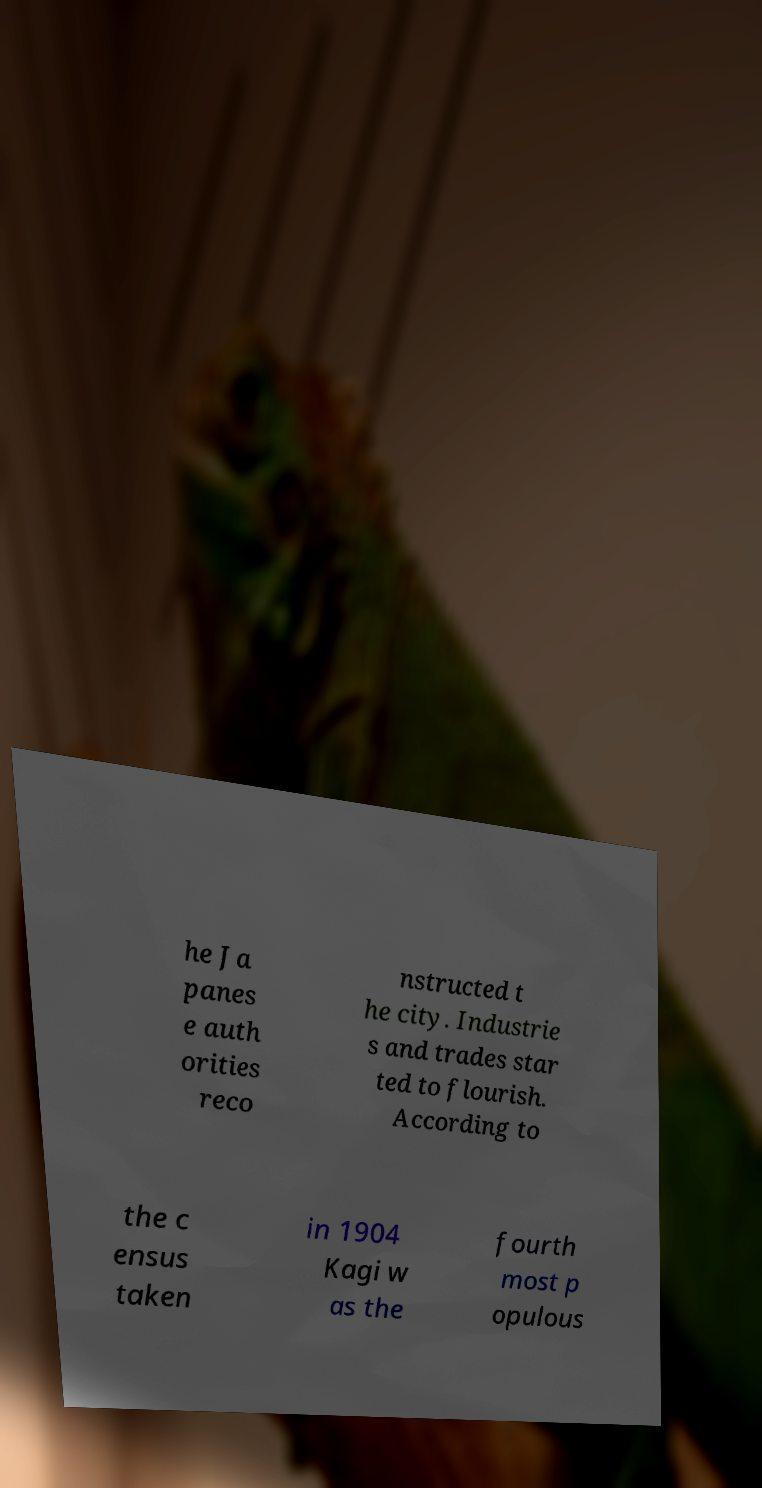I need the written content from this picture converted into text. Can you do that? he Ja panes e auth orities reco nstructed t he city. Industrie s and trades star ted to flourish. According to the c ensus taken in 1904 Kagi w as the fourth most p opulous 